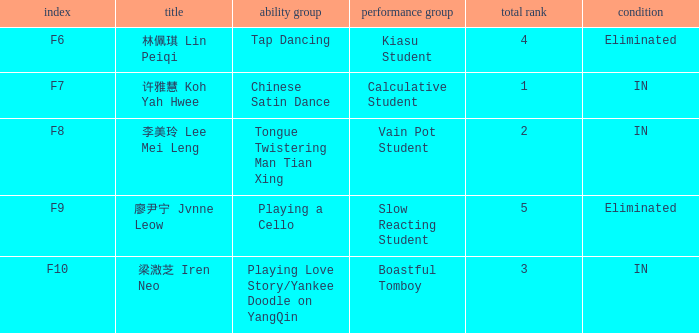What's the total number of overall rankings of 廖尹宁 jvnne leow's events that are eliminated? 1.0. 